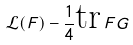Convert formula to latex. <formula><loc_0><loc_0><loc_500><loc_500>\mathcal { L } ( F ) - \frac { 1 } { 4 } \text {tr} \, F G</formula> 